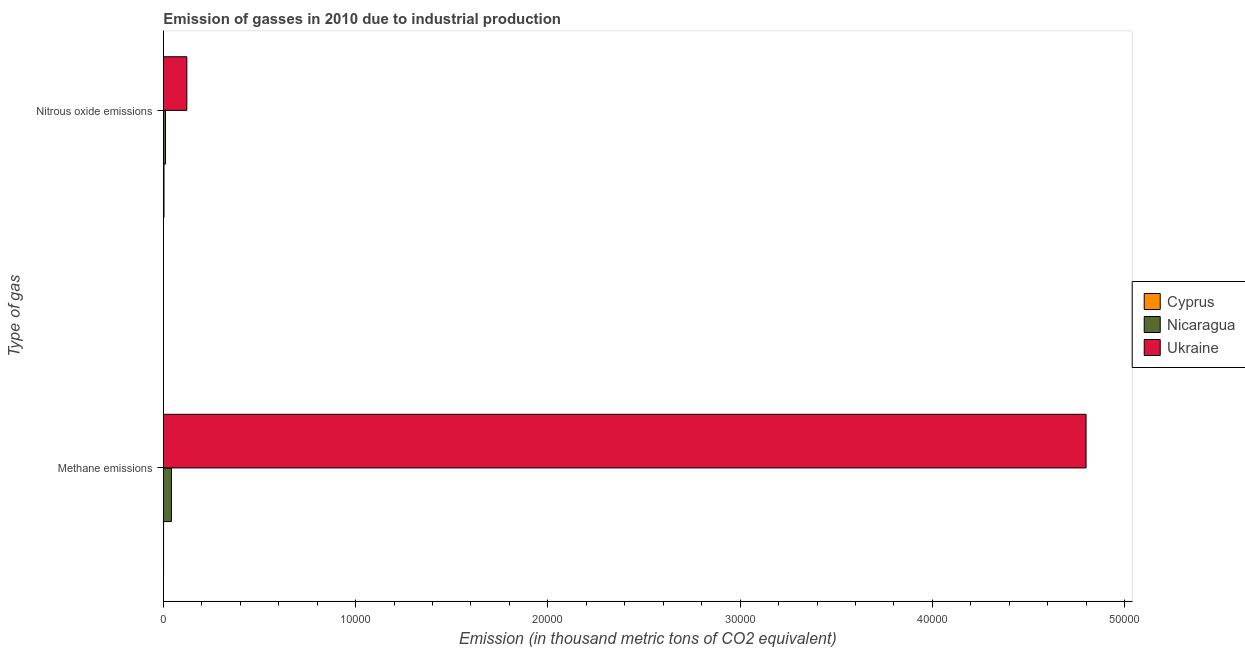How many different coloured bars are there?
Offer a very short reply. 3. Are the number of bars per tick equal to the number of legend labels?
Your answer should be compact. Yes. How many bars are there on the 2nd tick from the top?
Provide a succinct answer. 3. How many bars are there on the 2nd tick from the bottom?
Provide a short and direct response. 3. What is the label of the 1st group of bars from the top?
Provide a succinct answer. Nitrous oxide emissions. What is the amount of nitrous oxide emissions in Nicaragua?
Your answer should be very brief. 115.4. Across all countries, what is the maximum amount of nitrous oxide emissions?
Offer a very short reply. 1223.7. Across all countries, what is the minimum amount of nitrous oxide emissions?
Your answer should be very brief. 36.2. In which country was the amount of methane emissions maximum?
Offer a terse response. Ukraine. In which country was the amount of methane emissions minimum?
Offer a very short reply. Cyprus. What is the total amount of nitrous oxide emissions in the graph?
Offer a terse response. 1375.3. What is the difference between the amount of nitrous oxide emissions in Nicaragua and that in Ukraine?
Provide a short and direct response. -1108.3. What is the difference between the amount of methane emissions in Cyprus and the amount of nitrous oxide emissions in Ukraine?
Your answer should be very brief. -1210.4. What is the average amount of methane emissions per country?
Offer a very short reply. 1.61e+04. What is the difference between the amount of nitrous oxide emissions and amount of methane emissions in Nicaragua?
Your answer should be very brief. -306.7. In how many countries, is the amount of methane emissions greater than 32000 thousand metric tons?
Ensure brevity in your answer.  1. What is the ratio of the amount of nitrous oxide emissions in Nicaragua to that in Ukraine?
Ensure brevity in your answer.  0.09. What does the 1st bar from the top in Methane emissions represents?
Your answer should be compact. Ukraine. What does the 2nd bar from the bottom in Methane emissions represents?
Give a very brief answer. Nicaragua. How many countries are there in the graph?
Ensure brevity in your answer.  3. Are the values on the major ticks of X-axis written in scientific E-notation?
Offer a very short reply. No. How many legend labels are there?
Your answer should be compact. 3. What is the title of the graph?
Your answer should be compact. Emission of gasses in 2010 due to industrial production. Does "Afghanistan" appear as one of the legend labels in the graph?
Ensure brevity in your answer.  No. What is the label or title of the X-axis?
Provide a short and direct response. Emission (in thousand metric tons of CO2 equivalent). What is the label or title of the Y-axis?
Give a very brief answer. Type of gas. What is the Emission (in thousand metric tons of CO2 equivalent) in Nicaragua in Methane emissions?
Your answer should be very brief. 422.1. What is the Emission (in thousand metric tons of CO2 equivalent) of Ukraine in Methane emissions?
Offer a terse response. 4.80e+04. What is the Emission (in thousand metric tons of CO2 equivalent) in Cyprus in Nitrous oxide emissions?
Offer a terse response. 36.2. What is the Emission (in thousand metric tons of CO2 equivalent) of Nicaragua in Nitrous oxide emissions?
Offer a very short reply. 115.4. What is the Emission (in thousand metric tons of CO2 equivalent) of Ukraine in Nitrous oxide emissions?
Offer a terse response. 1223.7. Across all Type of gas, what is the maximum Emission (in thousand metric tons of CO2 equivalent) of Cyprus?
Give a very brief answer. 36.2. Across all Type of gas, what is the maximum Emission (in thousand metric tons of CO2 equivalent) in Nicaragua?
Make the answer very short. 422.1. Across all Type of gas, what is the maximum Emission (in thousand metric tons of CO2 equivalent) of Ukraine?
Provide a short and direct response. 4.80e+04. Across all Type of gas, what is the minimum Emission (in thousand metric tons of CO2 equivalent) in Cyprus?
Your answer should be compact. 13.3. Across all Type of gas, what is the minimum Emission (in thousand metric tons of CO2 equivalent) of Nicaragua?
Provide a short and direct response. 115.4. Across all Type of gas, what is the minimum Emission (in thousand metric tons of CO2 equivalent) of Ukraine?
Offer a terse response. 1223.7. What is the total Emission (in thousand metric tons of CO2 equivalent) in Cyprus in the graph?
Make the answer very short. 49.5. What is the total Emission (in thousand metric tons of CO2 equivalent) of Nicaragua in the graph?
Your answer should be very brief. 537.5. What is the total Emission (in thousand metric tons of CO2 equivalent) of Ukraine in the graph?
Provide a short and direct response. 4.92e+04. What is the difference between the Emission (in thousand metric tons of CO2 equivalent) in Cyprus in Methane emissions and that in Nitrous oxide emissions?
Provide a short and direct response. -22.9. What is the difference between the Emission (in thousand metric tons of CO2 equivalent) of Nicaragua in Methane emissions and that in Nitrous oxide emissions?
Your answer should be compact. 306.7. What is the difference between the Emission (in thousand metric tons of CO2 equivalent) of Ukraine in Methane emissions and that in Nitrous oxide emissions?
Offer a terse response. 4.68e+04. What is the difference between the Emission (in thousand metric tons of CO2 equivalent) of Cyprus in Methane emissions and the Emission (in thousand metric tons of CO2 equivalent) of Nicaragua in Nitrous oxide emissions?
Keep it short and to the point. -102.1. What is the difference between the Emission (in thousand metric tons of CO2 equivalent) of Cyprus in Methane emissions and the Emission (in thousand metric tons of CO2 equivalent) of Ukraine in Nitrous oxide emissions?
Keep it short and to the point. -1210.4. What is the difference between the Emission (in thousand metric tons of CO2 equivalent) of Nicaragua in Methane emissions and the Emission (in thousand metric tons of CO2 equivalent) of Ukraine in Nitrous oxide emissions?
Your answer should be compact. -801.6. What is the average Emission (in thousand metric tons of CO2 equivalent) of Cyprus per Type of gas?
Your answer should be compact. 24.75. What is the average Emission (in thousand metric tons of CO2 equivalent) of Nicaragua per Type of gas?
Offer a very short reply. 268.75. What is the average Emission (in thousand metric tons of CO2 equivalent) of Ukraine per Type of gas?
Your response must be concise. 2.46e+04. What is the difference between the Emission (in thousand metric tons of CO2 equivalent) of Cyprus and Emission (in thousand metric tons of CO2 equivalent) of Nicaragua in Methane emissions?
Your answer should be very brief. -408.8. What is the difference between the Emission (in thousand metric tons of CO2 equivalent) in Cyprus and Emission (in thousand metric tons of CO2 equivalent) in Ukraine in Methane emissions?
Keep it short and to the point. -4.80e+04. What is the difference between the Emission (in thousand metric tons of CO2 equivalent) of Nicaragua and Emission (in thousand metric tons of CO2 equivalent) of Ukraine in Methane emissions?
Keep it short and to the point. -4.76e+04. What is the difference between the Emission (in thousand metric tons of CO2 equivalent) of Cyprus and Emission (in thousand metric tons of CO2 equivalent) of Nicaragua in Nitrous oxide emissions?
Your answer should be compact. -79.2. What is the difference between the Emission (in thousand metric tons of CO2 equivalent) of Cyprus and Emission (in thousand metric tons of CO2 equivalent) of Ukraine in Nitrous oxide emissions?
Provide a short and direct response. -1187.5. What is the difference between the Emission (in thousand metric tons of CO2 equivalent) in Nicaragua and Emission (in thousand metric tons of CO2 equivalent) in Ukraine in Nitrous oxide emissions?
Offer a terse response. -1108.3. What is the ratio of the Emission (in thousand metric tons of CO2 equivalent) of Cyprus in Methane emissions to that in Nitrous oxide emissions?
Make the answer very short. 0.37. What is the ratio of the Emission (in thousand metric tons of CO2 equivalent) in Nicaragua in Methane emissions to that in Nitrous oxide emissions?
Your response must be concise. 3.66. What is the ratio of the Emission (in thousand metric tons of CO2 equivalent) in Ukraine in Methane emissions to that in Nitrous oxide emissions?
Make the answer very short. 39.22. What is the difference between the highest and the second highest Emission (in thousand metric tons of CO2 equivalent) of Cyprus?
Your response must be concise. 22.9. What is the difference between the highest and the second highest Emission (in thousand metric tons of CO2 equivalent) in Nicaragua?
Offer a very short reply. 306.7. What is the difference between the highest and the second highest Emission (in thousand metric tons of CO2 equivalent) in Ukraine?
Offer a very short reply. 4.68e+04. What is the difference between the highest and the lowest Emission (in thousand metric tons of CO2 equivalent) of Cyprus?
Your response must be concise. 22.9. What is the difference between the highest and the lowest Emission (in thousand metric tons of CO2 equivalent) in Nicaragua?
Keep it short and to the point. 306.7. What is the difference between the highest and the lowest Emission (in thousand metric tons of CO2 equivalent) in Ukraine?
Offer a very short reply. 4.68e+04. 